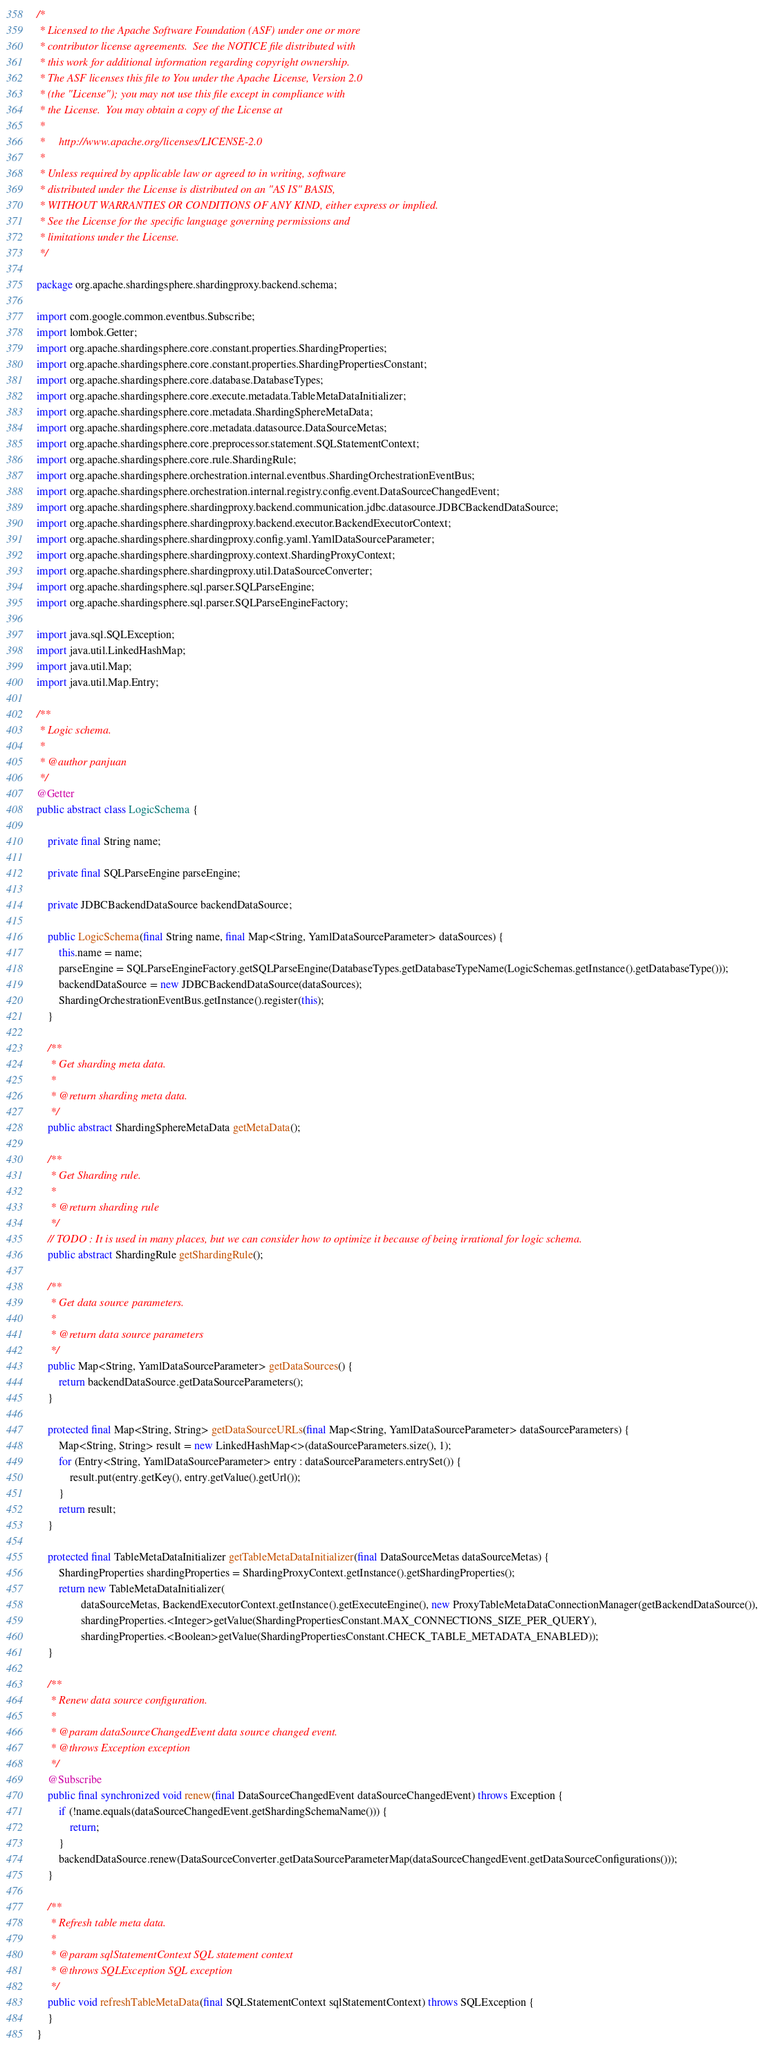<code> <loc_0><loc_0><loc_500><loc_500><_Java_>/*
 * Licensed to the Apache Software Foundation (ASF) under one or more
 * contributor license agreements.  See the NOTICE file distributed with
 * this work for additional information regarding copyright ownership.
 * The ASF licenses this file to You under the Apache License, Version 2.0
 * (the "License"); you may not use this file except in compliance with
 * the License.  You may obtain a copy of the License at
 *
 *     http://www.apache.org/licenses/LICENSE-2.0
 *
 * Unless required by applicable law or agreed to in writing, software
 * distributed under the License is distributed on an "AS IS" BASIS,
 * WITHOUT WARRANTIES OR CONDITIONS OF ANY KIND, either express or implied.
 * See the License for the specific language governing permissions and
 * limitations under the License.
 */

package org.apache.shardingsphere.shardingproxy.backend.schema;

import com.google.common.eventbus.Subscribe;
import lombok.Getter;
import org.apache.shardingsphere.core.constant.properties.ShardingProperties;
import org.apache.shardingsphere.core.constant.properties.ShardingPropertiesConstant;
import org.apache.shardingsphere.core.database.DatabaseTypes;
import org.apache.shardingsphere.core.execute.metadata.TableMetaDataInitializer;
import org.apache.shardingsphere.core.metadata.ShardingSphereMetaData;
import org.apache.shardingsphere.core.metadata.datasource.DataSourceMetas;
import org.apache.shardingsphere.core.preprocessor.statement.SQLStatementContext;
import org.apache.shardingsphere.core.rule.ShardingRule;
import org.apache.shardingsphere.orchestration.internal.eventbus.ShardingOrchestrationEventBus;
import org.apache.shardingsphere.orchestration.internal.registry.config.event.DataSourceChangedEvent;
import org.apache.shardingsphere.shardingproxy.backend.communication.jdbc.datasource.JDBCBackendDataSource;
import org.apache.shardingsphere.shardingproxy.backend.executor.BackendExecutorContext;
import org.apache.shardingsphere.shardingproxy.config.yaml.YamlDataSourceParameter;
import org.apache.shardingsphere.shardingproxy.context.ShardingProxyContext;
import org.apache.shardingsphere.shardingproxy.util.DataSourceConverter;
import org.apache.shardingsphere.sql.parser.SQLParseEngine;
import org.apache.shardingsphere.sql.parser.SQLParseEngineFactory;

import java.sql.SQLException;
import java.util.LinkedHashMap;
import java.util.Map;
import java.util.Map.Entry;

/**
 * Logic schema.
 *
 * @author panjuan
 */
@Getter
public abstract class LogicSchema {
    
    private final String name;
    
    private final SQLParseEngine parseEngine;
    
    private JDBCBackendDataSource backendDataSource;
    
    public LogicSchema(final String name, final Map<String, YamlDataSourceParameter> dataSources) {
        this.name = name;
        parseEngine = SQLParseEngineFactory.getSQLParseEngine(DatabaseTypes.getDatabaseTypeName(LogicSchemas.getInstance().getDatabaseType()));
        backendDataSource = new JDBCBackendDataSource(dataSources);
        ShardingOrchestrationEventBus.getInstance().register(this);
    }
    
    /**
     * Get sharding meta data.
     * 
     * @return sharding meta data.
     */
    public abstract ShardingSphereMetaData getMetaData();
    
    /**
     * Get Sharding rule.
     * 
     * @return sharding rule
     */
    // TODO : It is used in many places, but we can consider how to optimize it because of being irrational for logic schema.
    public abstract ShardingRule getShardingRule();
    
    /**
     * Get data source parameters.
     * 
     * @return data source parameters
     */
    public Map<String, YamlDataSourceParameter> getDataSources() {
        return backendDataSource.getDataSourceParameters();
    }
    
    protected final Map<String, String> getDataSourceURLs(final Map<String, YamlDataSourceParameter> dataSourceParameters) {
        Map<String, String> result = new LinkedHashMap<>(dataSourceParameters.size(), 1);
        for (Entry<String, YamlDataSourceParameter> entry : dataSourceParameters.entrySet()) {
            result.put(entry.getKey(), entry.getValue().getUrl());
        }
        return result;
    }
    
    protected final TableMetaDataInitializer getTableMetaDataInitializer(final DataSourceMetas dataSourceMetas) {
        ShardingProperties shardingProperties = ShardingProxyContext.getInstance().getShardingProperties();
        return new TableMetaDataInitializer(
                dataSourceMetas, BackendExecutorContext.getInstance().getExecuteEngine(), new ProxyTableMetaDataConnectionManager(getBackendDataSource()),
                shardingProperties.<Integer>getValue(ShardingPropertiesConstant.MAX_CONNECTIONS_SIZE_PER_QUERY),
                shardingProperties.<Boolean>getValue(ShardingPropertiesConstant.CHECK_TABLE_METADATA_ENABLED));
    }
    
    /**
     * Renew data source configuration.
     *
     * @param dataSourceChangedEvent data source changed event.
     * @throws Exception exception
     */
    @Subscribe
    public final synchronized void renew(final DataSourceChangedEvent dataSourceChangedEvent) throws Exception {
        if (!name.equals(dataSourceChangedEvent.getShardingSchemaName())) {
            return;
        }
        backendDataSource.renew(DataSourceConverter.getDataSourceParameterMap(dataSourceChangedEvent.getDataSourceConfigurations()));
    }
    
    /**
     * Refresh table meta data.
     * 
     * @param sqlStatementContext SQL statement context
     * @throws SQLException SQL exception
     */
    public void refreshTableMetaData(final SQLStatementContext sqlStatementContext) throws SQLException {
    }
}
</code> 